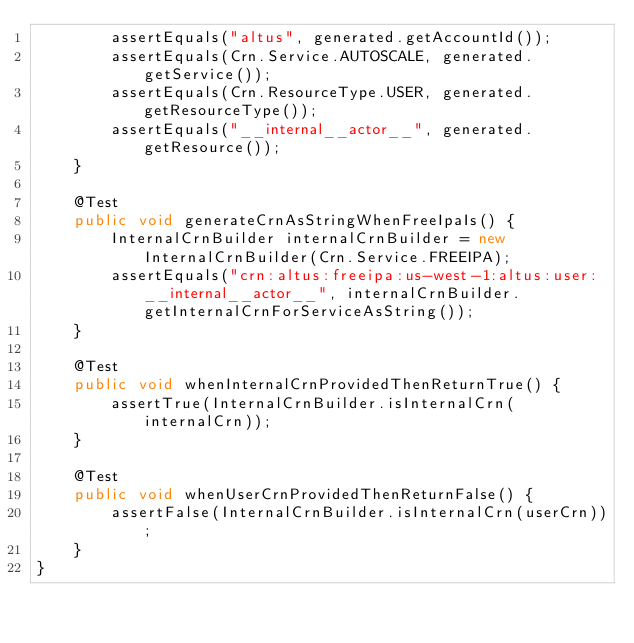Convert code to text. <code><loc_0><loc_0><loc_500><loc_500><_Java_>        assertEquals("altus", generated.getAccountId());
        assertEquals(Crn.Service.AUTOSCALE, generated.getService());
        assertEquals(Crn.ResourceType.USER, generated.getResourceType());
        assertEquals("__internal__actor__", generated.getResource());
    }

    @Test
    public void generateCrnAsStringWhenFreeIpaIs() {
        InternalCrnBuilder internalCrnBuilder = new InternalCrnBuilder(Crn.Service.FREEIPA);
        assertEquals("crn:altus:freeipa:us-west-1:altus:user:__internal__actor__", internalCrnBuilder.getInternalCrnForServiceAsString());
    }

    @Test
    public void whenInternalCrnProvidedThenReturnTrue() {
        assertTrue(InternalCrnBuilder.isInternalCrn(internalCrn));
    }

    @Test
    public void whenUserCrnProvidedThenReturnFalse() {
        assertFalse(InternalCrnBuilder.isInternalCrn(userCrn));
    }
}</code> 